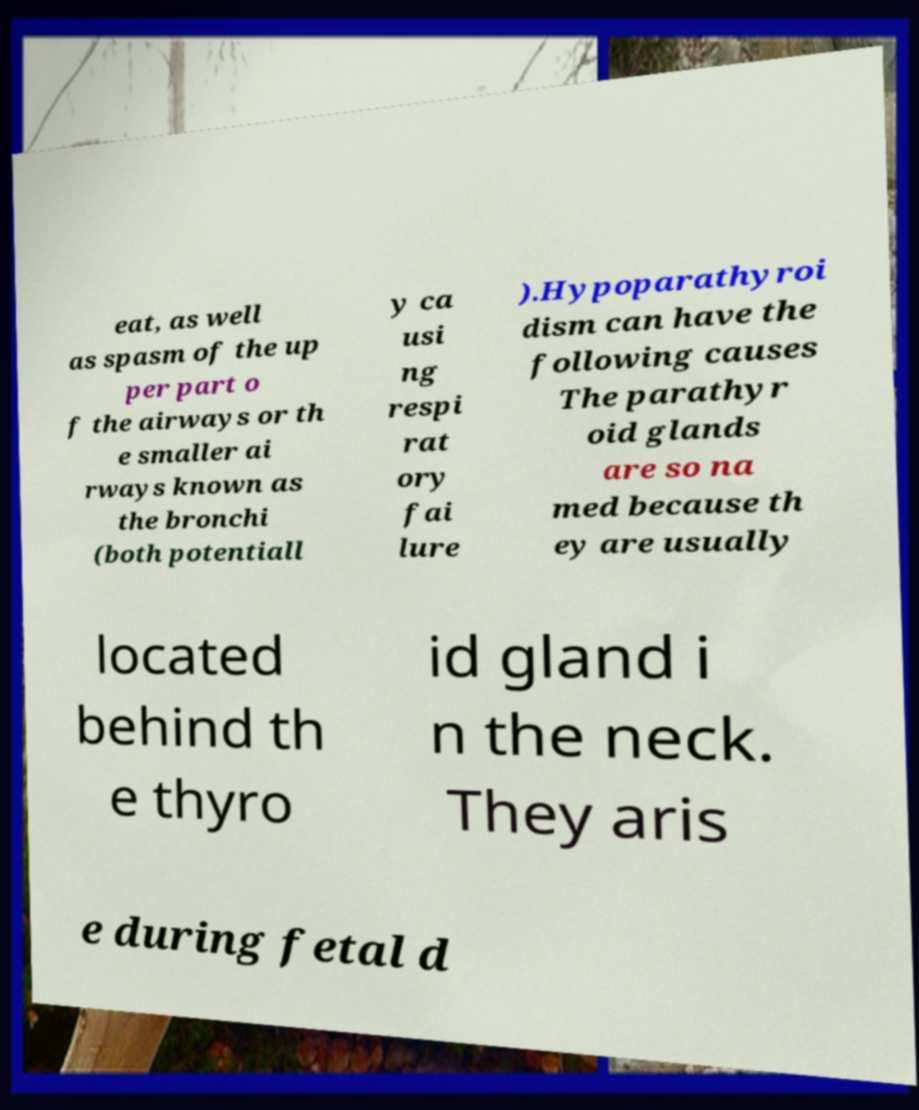What messages or text are displayed in this image? I need them in a readable, typed format. eat, as well as spasm of the up per part o f the airways or th e smaller ai rways known as the bronchi (both potentiall y ca usi ng respi rat ory fai lure ).Hypoparathyroi dism can have the following causes The parathyr oid glands are so na med because th ey are usually located behind th e thyro id gland i n the neck. They aris e during fetal d 